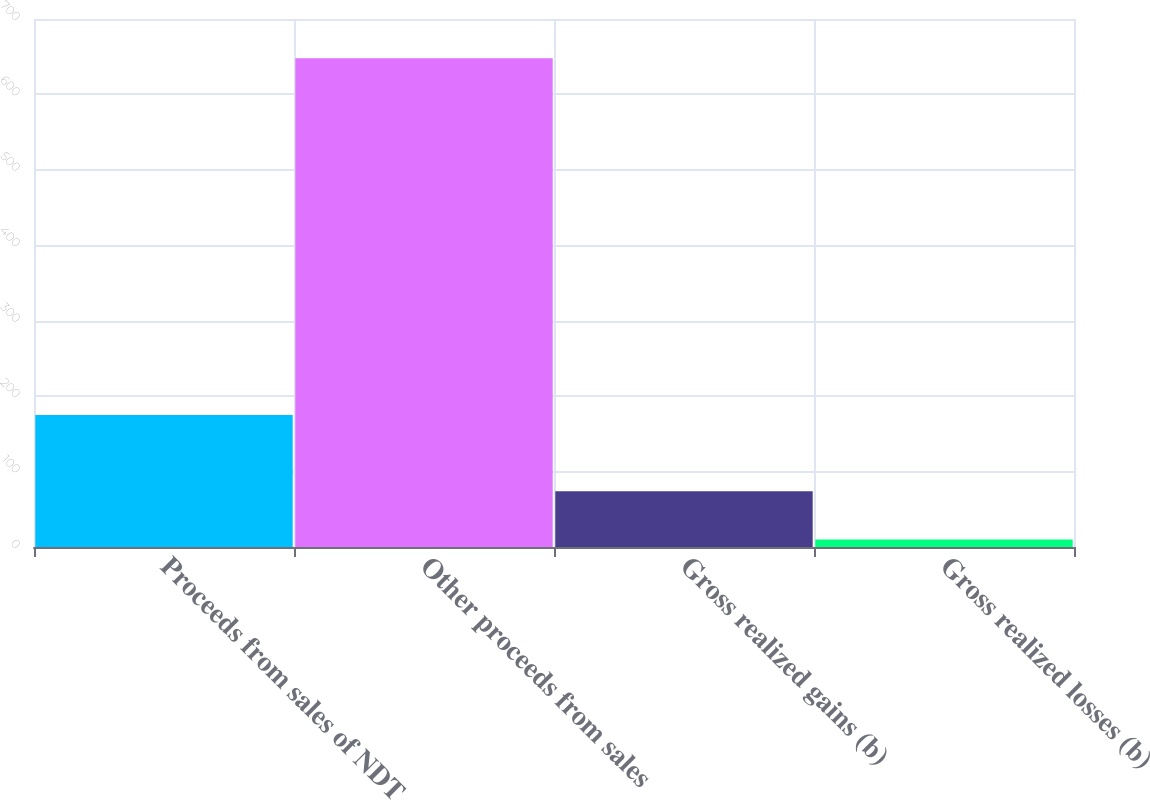Convert chart. <chart><loc_0><loc_0><loc_500><loc_500><bar_chart><fcel>Proceeds from sales of NDT<fcel>Other proceeds from sales<fcel>Gross realized gains (b)<fcel>Gross realized losses (b)<nl><fcel>175<fcel>648<fcel>73.8<fcel>10<nl></chart> 